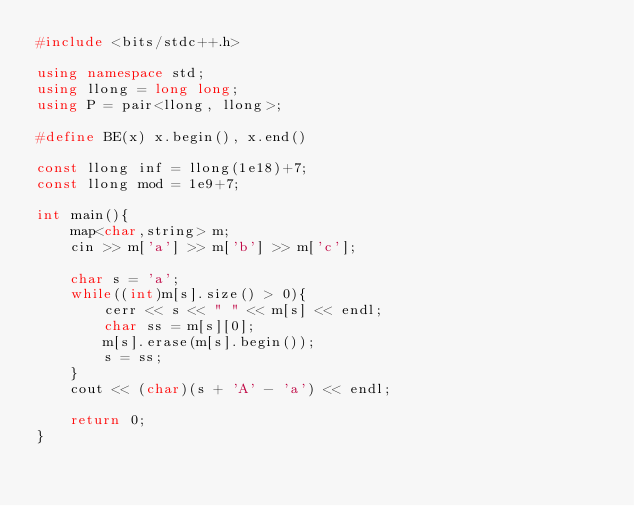<code> <loc_0><loc_0><loc_500><loc_500><_C++_>#include <bits/stdc++.h>

using namespace std;
using llong = long long;
using P = pair<llong, llong>;

#define BE(x) x.begin(), x.end()

const llong inf = llong(1e18)+7;
const llong mod = 1e9+7;

int main(){
	map<char,string> m;
	cin >> m['a'] >> m['b'] >> m['c'];

	char s = 'a';
	while((int)m[s].size() > 0){
		cerr << s << " " << m[s] << endl;
		char ss = m[s][0];
		m[s].erase(m[s].begin());
		s = ss;
	}
	cout << (char)(s + 'A' - 'a') << endl;

	return 0;
}</code> 